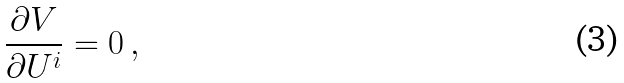<formula> <loc_0><loc_0><loc_500><loc_500>\frac { \partial V } { \partial U ^ { i } } = 0 \, ,</formula> 